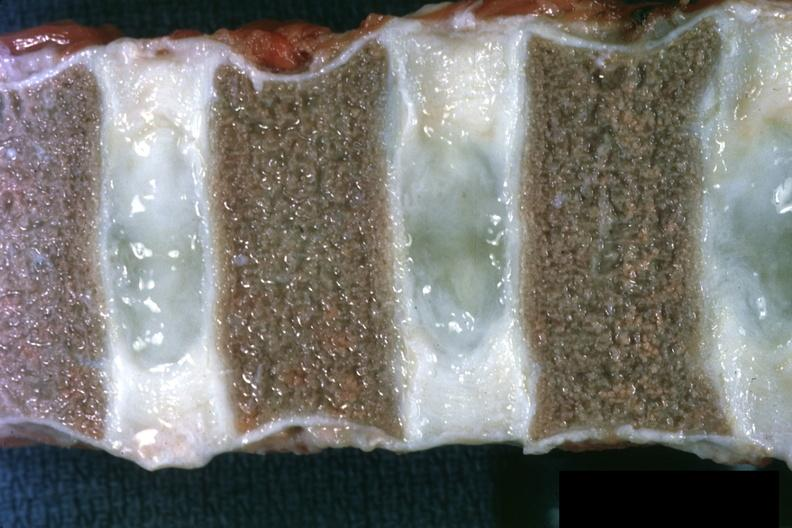what is present?
Answer the question using a single word or phrase. Bone marrow 